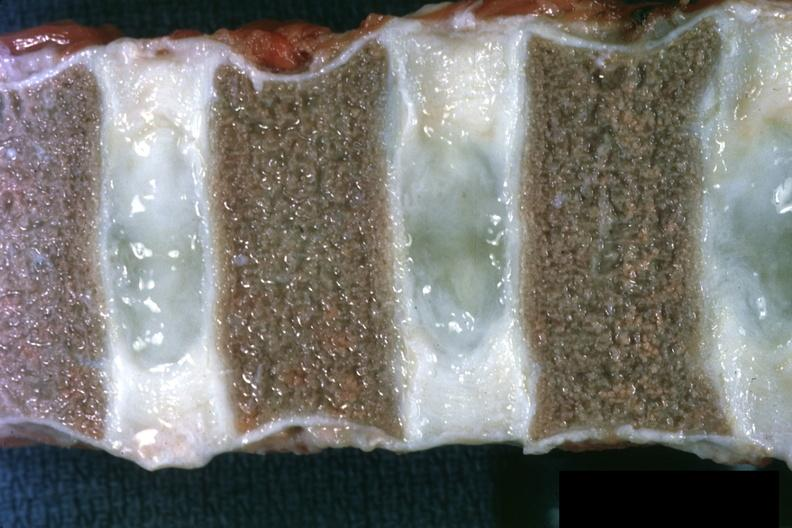what is present?
Answer the question using a single word or phrase. Bone marrow 